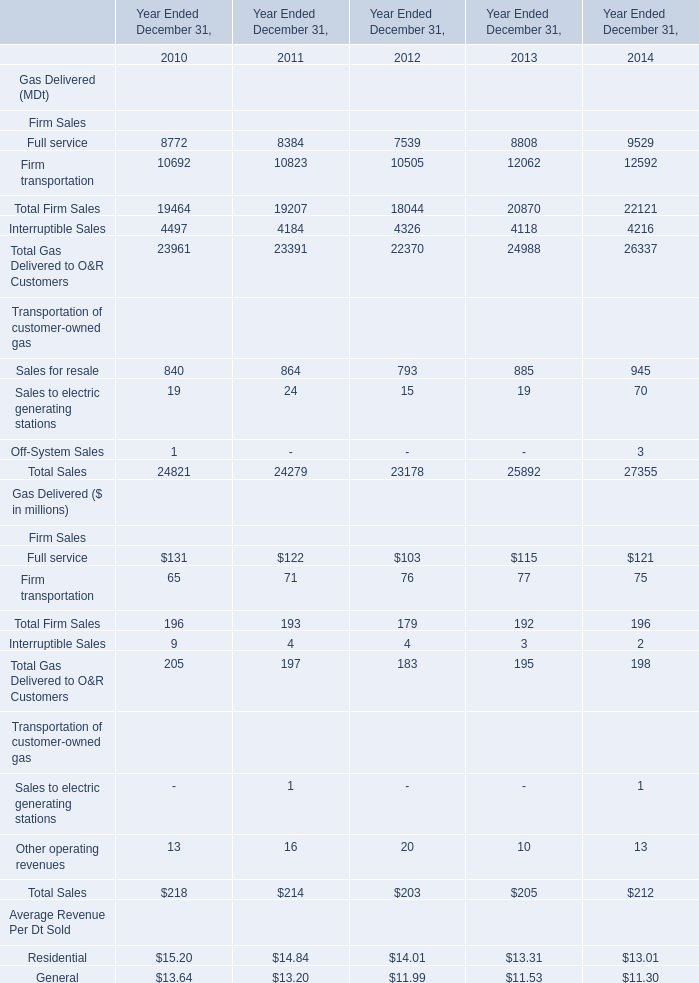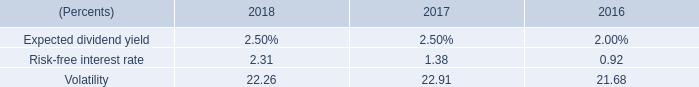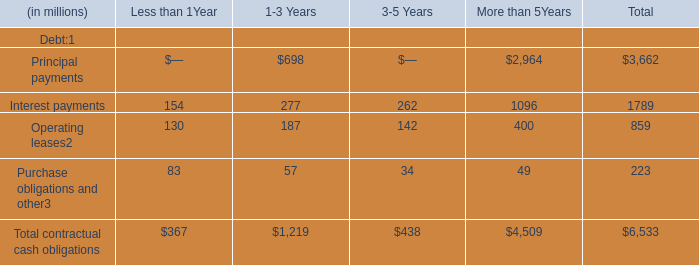What's the growth rate of total Firm Sales in 2014? 
Computations: ((196 - 192) / 192)
Answer: 0.02083. 